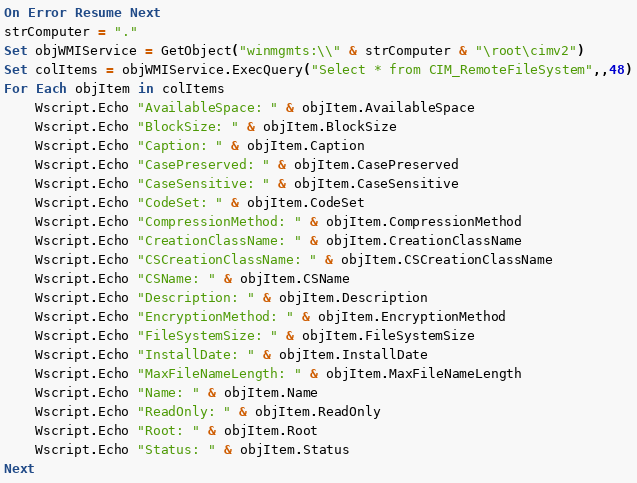<code> <loc_0><loc_0><loc_500><loc_500><_VisualBasic_>On Error Resume Next
strComputer = "."
Set objWMIService = GetObject("winmgmts:\\" & strComputer & "\root\cimv2")
Set colItems = objWMIService.ExecQuery("Select * from CIM_RemoteFileSystem",,48)
For Each objItem in colItems
    Wscript.Echo "AvailableSpace: " & objItem.AvailableSpace
    Wscript.Echo "BlockSize: " & objItem.BlockSize
    Wscript.Echo "Caption: " & objItem.Caption
    Wscript.Echo "CasePreserved: " & objItem.CasePreserved
    Wscript.Echo "CaseSensitive: " & objItem.CaseSensitive
    Wscript.Echo "CodeSet: " & objItem.CodeSet
    Wscript.Echo "CompressionMethod: " & objItem.CompressionMethod
    Wscript.Echo "CreationClassName: " & objItem.CreationClassName
    Wscript.Echo "CSCreationClassName: " & objItem.CSCreationClassName
    Wscript.Echo "CSName: " & objItem.CSName
    Wscript.Echo "Description: " & objItem.Description
    Wscript.Echo "EncryptionMethod: " & objItem.EncryptionMethod
    Wscript.Echo "FileSystemSize: " & objItem.FileSystemSize
    Wscript.Echo "InstallDate: " & objItem.InstallDate
    Wscript.Echo "MaxFileNameLength: " & objItem.MaxFileNameLength
    Wscript.Echo "Name: " & objItem.Name
    Wscript.Echo "ReadOnly: " & objItem.ReadOnly
    Wscript.Echo "Root: " & objItem.Root
    Wscript.Echo "Status: " & objItem.Status
Next

</code> 